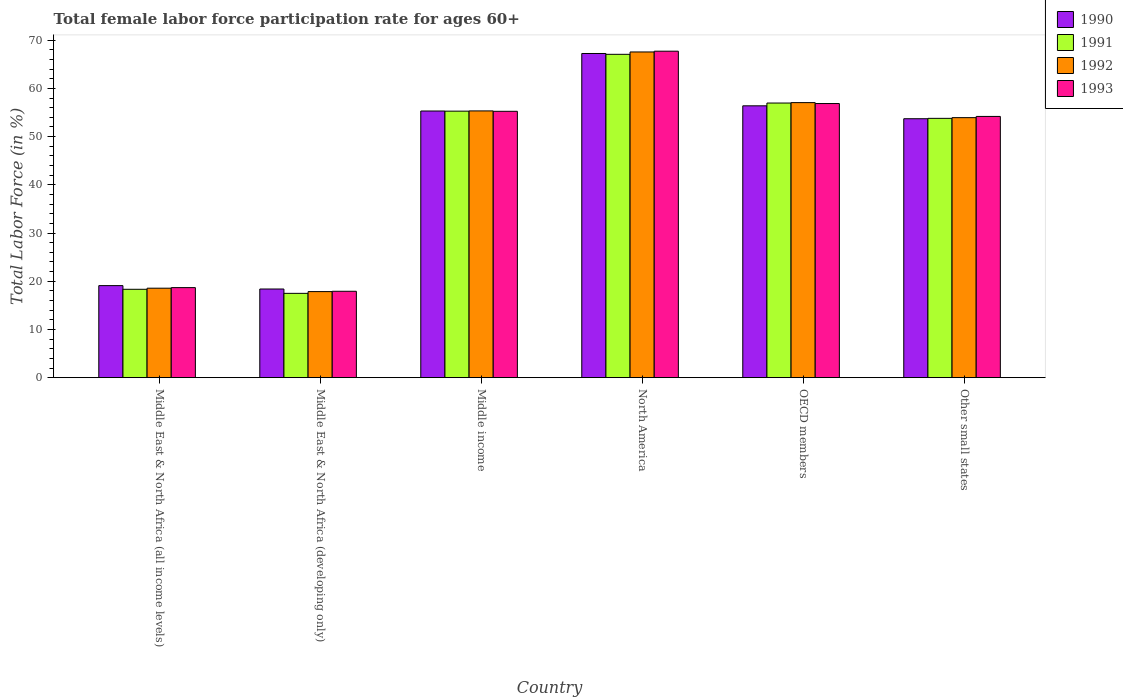Are the number of bars per tick equal to the number of legend labels?
Your answer should be very brief. Yes. How many bars are there on the 2nd tick from the left?
Your response must be concise. 4. What is the label of the 1st group of bars from the left?
Provide a short and direct response. Middle East & North Africa (all income levels). In how many cases, is the number of bars for a given country not equal to the number of legend labels?
Provide a short and direct response. 0. What is the female labor force participation rate in 1990 in Middle East & North Africa (all income levels)?
Offer a very short reply. 19.09. Across all countries, what is the maximum female labor force participation rate in 1991?
Your response must be concise. 67.06. Across all countries, what is the minimum female labor force participation rate in 1993?
Your response must be concise. 17.92. In which country was the female labor force participation rate in 1992 maximum?
Provide a short and direct response. North America. In which country was the female labor force participation rate in 1991 minimum?
Give a very brief answer. Middle East & North Africa (developing only). What is the total female labor force participation rate in 1992 in the graph?
Offer a very short reply. 270.26. What is the difference between the female labor force participation rate in 1991 in North America and that in Other small states?
Make the answer very short. 13.28. What is the difference between the female labor force participation rate in 1990 in OECD members and the female labor force participation rate in 1992 in Middle East & North Africa (developing only)?
Offer a very short reply. 38.53. What is the average female labor force participation rate in 1992 per country?
Your response must be concise. 45.04. What is the difference between the female labor force participation rate of/in 1990 and female labor force participation rate of/in 1991 in Other small states?
Your answer should be compact. -0.08. What is the ratio of the female labor force participation rate in 1991 in Middle East & North Africa (developing only) to that in Middle income?
Provide a short and direct response. 0.32. Is the difference between the female labor force participation rate in 1990 in Middle East & North Africa (developing only) and Other small states greater than the difference between the female labor force participation rate in 1991 in Middle East & North Africa (developing only) and Other small states?
Provide a succinct answer. Yes. What is the difference between the highest and the second highest female labor force participation rate in 1992?
Offer a very short reply. -10.51. What is the difference between the highest and the lowest female labor force participation rate in 1992?
Provide a succinct answer. 49.7. What does the 3rd bar from the left in Middle East & North Africa (developing only) represents?
Your response must be concise. 1992. Is it the case that in every country, the sum of the female labor force participation rate in 1993 and female labor force participation rate in 1990 is greater than the female labor force participation rate in 1991?
Provide a short and direct response. Yes. How many bars are there?
Give a very brief answer. 24. Are all the bars in the graph horizontal?
Offer a very short reply. No. What is the difference between two consecutive major ticks on the Y-axis?
Offer a terse response. 10. Does the graph contain any zero values?
Your answer should be very brief. No. What is the title of the graph?
Ensure brevity in your answer.  Total female labor force participation rate for ages 60+. Does "2006" appear as one of the legend labels in the graph?
Keep it short and to the point. No. What is the label or title of the X-axis?
Your answer should be very brief. Country. What is the label or title of the Y-axis?
Keep it short and to the point. Total Labor Force (in %). What is the Total Labor Force (in %) of 1990 in Middle East & North Africa (all income levels)?
Offer a very short reply. 19.09. What is the Total Labor Force (in %) in 1991 in Middle East & North Africa (all income levels)?
Offer a terse response. 18.33. What is the Total Labor Force (in %) of 1992 in Middle East & North Africa (all income levels)?
Your answer should be very brief. 18.56. What is the Total Labor Force (in %) in 1993 in Middle East & North Africa (all income levels)?
Keep it short and to the point. 18.68. What is the Total Labor Force (in %) of 1990 in Middle East & North Africa (developing only)?
Provide a succinct answer. 18.39. What is the Total Labor Force (in %) of 1991 in Middle East & North Africa (developing only)?
Make the answer very short. 17.49. What is the Total Labor Force (in %) in 1992 in Middle East & North Africa (developing only)?
Ensure brevity in your answer.  17.85. What is the Total Labor Force (in %) in 1993 in Middle East & North Africa (developing only)?
Keep it short and to the point. 17.92. What is the Total Labor Force (in %) in 1990 in Middle income?
Provide a short and direct response. 55.31. What is the Total Labor Force (in %) of 1991 in Middle income?
Offer a terse response. 55.28. What is the Total Labor Force (in %) of 1992 in Middle income?
Offer a very short reply. 55.33. What is the Total Labor Force (in %) of 1993 in Middle income?
Your response must be concise. 55.24. What is the Total Labor Force (in %) in 1990 in North America?
Provide a short and direct response. 67.23. What is the Total Labor Force (in %) of 1991 in North America?
Make the answer very short. 67.06. What is the Total Labor Force (in %) of 1992 in North America?
Provide a succinct answer. 67.55. What is the Total Labor Force (in %) of 1993 in North America?
Provide a short and direct response. 67.71. What is the Total Labor Force (in %) in 1990 in OECD members?
Offer a terse response. 56.38. What is the Total Labor Force (in %) of 1991 in OECD members?
Give a very brief answer. 56.96. What is the Total Labor Force (in %) in 1992 in OECD members?
Make the answer very short. 57.05. What is the Total Labor Force (in %) in 1993 in OECD members?
Provide a short and direct response. 56.86. What is the Total Labor Force (in %) of 1990 in Other small states?
Your response must be concise. 53.71. What is the Total Labor Force (in %) of 1991 in Other small states?
Provide a succinct answer. 53.78. What is the Total Labor Force (in %) of 1992 in Other small states?
Give a very brief answer. 53.93. What is the Total Labor Force (in %) in 1993 in Other small states?
Offer a very short reply. 54.18. Across all countries, what is the maximum Total Labor Force (in %) of 1990?
Make the answer very short. 67.23. Across all countries, what is the maximum Total Labor Force (in %) in 1991?
Ensure brevity in your answer.  67.06. Across all countries, what is the maximum Total Labor Force (in %) in 1992?
Keep it short and to the point. 67.55. Across all countries, what is the maximum Total Labor Force (in %) in 1993?
Provide a succinct answer. 67.71. Across all countries, what is the minimum Total Labor Force (in %) of 1990?
Provide a short and direct response. 18.39. Across all countries, what is the minimum Total Labor Force (in %) of 1991?
Ensure brevity in your answer.  17.49. Across all countries, what is the minimum Total Labor Force (in %) of 1992?
Your answer should be very brief. 17.85. Across all countries, what is the minimum Total Labor Force (in %) in 1993?
Provide a short and direct response. 17.92. What is the total Total Labor Force (in %) in 1990 in the graph?
Offer a very short reply. 270.1. What is the total Total Labor Force (in %) in 1991 in the graph?
Keep it short and to the point. 268.9. What is the total Total Labor Force (in %) of 1992 in the graph?
Provide a short and direct response. 270.26. What is the total Total Labor Force (in %) in 1993 in the graph?
Provide a short and direct response. 270.59. What is the difference between the Total Labor Force (in %) in 1990 in Middle East & North Africa (all income levels) and that in Middle East & North Africa (developing only)?
Make the answer very short. 0.7. What is the difference between the Total Labor Force (in %) of 1991 in Middle East & North Africa (all income levels) and that in Middle East & North Africa (developing only)?
Provide a succinct answer. 0.84. What is the difference between the Total Labor Force (in %) of 1992 in Middle East & North Africa (all income levels) and that in Middle East & North Africa (developing only)?
Provide a succinct answer. 0.71. What is the difference between the Total Labor Force (in %) of 1993 in Middle East & North Africa (all income levels) and that in Middle East & North Africa (developing only)?
Offer a very short reply. 0.76. What is the difference between the Total Labor Force (in %) of 1990 in Middle East & North Africa (all income levels) and that in Middle income?
Your answer should be very brief. -36.21. What is the difference between the Total Labor Force (in %) of 1991 in Middle East & North Africa (all income levels) and that in Middle income?
Provide a short and direct response. -36.95. What is the difference between the Total Labor Force (in %) of 1992 in Middle East & North Africa (all income levels) and that in Middle income?
Offer a very short reply. -36.77. What is the difference between the Total Labor Force (in %) of 1993 in Middle East & North Africa (all income levels) and that in Middle income?
Your response must be concise. -36.57. What is the difference between the Total Labor Force (in %) in 1990 in Middle East & North Africa (all income levels) and that in North America?
Offer a very short reply. -48.14. What is the difference between the Total Labor Force (in %) in 1991 in Middle East & North Africa (all income levels) and that in North America?
Make the answer very short. -48.73. What is the difference between the Total Labor Force (in %) of 1992 in Middle East & North Africa (all income levels) and that in North America?
Make the answer very short. -48.99. What is the difference between the Total Labor Force (in %) in 1993 in Middle East & North Africa (all income levels) and that in North America?
Give a very brief answer. -49.03. What is the difference between the Total Labor Force (in %) in 1990 in Middle East & North Africa (all income levels) and that in OECD members?
Ensure brevity in your answer.  -37.29. What is the difference between the Total Labor Force (in %) in 1991 in Middle East & North Africa (all income levels) and that in OECD members?
Your response must be concise. -38.63. What is the difference between the Total Labor Force (in %) in 1992 in Middle East & North Africa (all income levels) and that in OECD members?
Offer a very short reply. -38.49. What is the difference between the Total Labor Force (in %) of 1993 in Middle East & North Africa (all income levels) and that in OECD members?
Your answer should be compact. -38.18. What is the difference between the Total Labor Force (in %) in 1990 in Middle East & North Africa (all income levels) and that in Other small states?
Provide a short and direct response. -34.61. What is the difference between the Total Labor Force (in %) in 1991 in Middle East & North Africa (all income levels) and that in Other small states?
Provide a succinct answer. -35.45. What is the difference between the Total Labor Force (in %) in 1992 in Middle East & North Africa (all income levels) and that in Other small states?
Offer a very short reply. -35.37. What is the difference between the Total Labor Force (in %) in 1993 in Middle East & North Africa (all income levels) and that in Other small states?
Offer a very short reply. -35.51. What is the difference between the Total Labor Force (in %) of 1990 in Middle East & North Africa (developing only) and that in Middle income?
Offer a very short reply. -36.92. What is the difference between the Total Labor Force (in %) of 1991 in Middle East & North Africa (developing only) and that in Middle income?
Offer a very short reply. -37.79. What is the difference between the Total Labor Force (in %) in 1992 in Middle East & North Africa (developing only) and that in Middle income?
Keep it short and to the point. -37.48. What is the difference between the Total Labor Force (in %) of 1993 in Middle East & North Africa (developing only) and that in Middle income?
Your answer should be very brief. -37.32. What is the difference between the Total Labor Force (in %) in 1990 in Middle East & North Africa (developing only) and that in North America?
Keep it short and to the point. -48.85. What is the difference between the Total Labor Force (in %) of 1991 in Middle East & North Africa (developing only) and that in North America?
Ensure brevity in your answer.  -49.58. What is the difference between the Total Labor Force (in %) of 1992 in Middle East & North Africa (developing only) and that in North America?
Your answer should be very brief. -49.7. What is the difference between the Total Labor Force (in %) in 1993 in Middle East & North Africa (developing only) and that in North America?
Provide a short and direct response. -49.79. What is the difference between the Total Labor Force (in %) in 1990 in Middle East & North Africa (developing only) and that in OECD members?
Give a very brief answer. -38. What is the difference between the Total Labor Force (in %) in 1991 in Middle East & North Africa (developing only) and that in OECD members?
Provide a short and direct response. -39.47. What is the difference between the Total Labor Force (in %) in 1992 in Middle East & North Africa (developing only) and that in OECD members?
Ensure brevity in your answer.  -39.2. What is the difference between the Total Labor Force (in %) in 1993 in Middle East & North Africa (developing only) and that in OECD members?
Provide a short and direct response. -38.94. What is the difference between the Total Labor Force (in %) in 1990 in Middle East & North Africa (developing only) and that in Other small states?
Keep it short and to the point. -35.32. What is the difference between the Total Labor Force (in %) of 1991 in Middle East & North Africa (developing only) and that in Other small states?
Provide a succinct answer. -36.3. What is the difference between the Total Labor Force (in %) of 1992 in Middle East & North Africa (developing only) and that in Other small states?
Provide a succinct answer. -36.08. What is the difference between the Total Labor Force (in %) of 1993 in Middle East & North Africa (developing only) and that in Other small states?
Provide a succinct answer. -36.26. What is the difference between the Total Labor Force (in %) of 1990 in Middle income and that in North America?
Give a very brief answer. -11.93. What is the difference between the Total Labor Force (in %) in 1991 in Middle income and that in North America?
Offer a very short reply. -11.79. What is the difference between the Total Labor Force (in %) in 1992 in Middle income and that in North America?
Your answer should be compact. -12.23. What is the difference between the Total Labor Force (in %) of 1993 in Middle income and that in North America?
Provide a succinct answer. -12.47. What is the difference between the Total Labor Force (in %) in 1990 in Middle income and that in OECD members?
Provide a short and direct response. -1.08. What is the difference between the Total Labor Force (in %) of 1991 in Middle income and that in OECD members?
Your answer should be very brief. -1.68. What is the difference between the Total Labor Force (in %) in 1992 in Middle income and that in OECD members?
Your response must be concise. -1.72. What is the difference between the Total Labor Force (in %) in 1993 in Middle income and that in OECD members?
Your answer should be compact. -1.61. What is the difference between the Total Labor Force (in %) in 1990 in Middle income and that in Other small states?
Your answer should be very brief. 1.6. What is the difference between the Total Labor Force (in %) in 1991 in Middle income and that in Other small states?
Your answer should be compact. 1.5. What is the difference between the Total Labor Force (in %) in 1992 in Middle income and that in Other small states?
Make the answer very short. 1.4. What is the difference between the Total Labor Force (in %) in 1993 in Middle income and that in Other small states?
Your answer should be compact. 1.06. What is the difference between the Total Labor Force (in %) in 1990 in North America and that in OECD members?
Your response must be concise. 10.85. What is the difference between the Total Labor Force (in %) in 1991 in North America and that in OECD members?
Your answer should be compact. 10.11. What is the difference between the Total Labor Force (in %) of 1992 in North America and that in OECD members?
Your response must be concise. 10.51. What is the difference between the Total Labor Force (in %) of 1993 in North America and that in OECD members?
Keep it short and to the point. 10.85. What is the difference between the Total Labor Force (in %) in 1990 in North America and that in Other small states?
Provide a succinct answer. 13.53. What is the difference between the Total Labor Force (in %) in 1991 in North America and that in Other small states?
Your response must be concise. 13.28. What is the difference between the Total Labor Force (in %) in 1992 in North America and that in Other small states?
Offer a terse response. 13.62. What is the difference between the Total Labor Force (in %) of 1993 in North America and that in Other small states?
Your answer should be compact. 13.53. What is the difference between the Total Labor Force (in %) in 1990 in OECD members and that in Other small states?
Make the answer very short. 2.68. What is the difference between the Total Labor Force (in %) of 1991 in OECD members and that in Other small states?
Keep it short and to the point. 3.17. What is the difference between the Total Labor Force (in %) of 1992 in OECD members and that in Other small states?
Your answer should be very brief. 3.12. What is the difference between the Total Labor Force (in %) in 1993 in OECD members and that in Other small states?
Keep it short and to the point. 2.67. What is the difference between the Total Labor Force (in %) in 1990 in Middle East & North Africa (all income levels) and the Total Labor Force (in %) in 1991 in Middle East & North Africa (developing only)?
Give a very brief answer. 1.6. What is the difference between the Total Labor Force (in %) of 1990 in Middle East & North Africa (all income levels) and the Total Labor Force (in %) of 1992 in Middle East & North Africa (developing only)?
Provide a short and direct response. 1.24. What is the difference between the Total Labor Force (in %) of 1990 in Middle East & North Africa (all income levels) and the Total Labor Force (in %) of 1993 in Middle East & North Africa (developing only)?
Your answer should be compact. 1.17. What is the difference between the Total Labor Force (in %) in 1991 in Middle East & North Africa (all income levels) and the Total Labor Force (in %) in 1992 in Middle East & North Africa (developing only)?
Give a very brief answer. 0.48. What is the difference between the Total Labor Force (in %) in 1991 in Middle East & North Africa (all income levels) and the Total Labor Force (in %) in 1993 in Middle East & North Africa (developing only)?
Offer a terse response. 0.41. What is the difference between the Total Labor Force (in %) of 1992 in Middle East & North Africa (all income levels) and the Total Labor Force (in %) of 1993 in Middle East & North Africa (developing only)?
Offer a very short reply. 0.64. What is the difference between the Total Labor Force (in %) of 1990 in Middle East & North Africa (all income levels) and the Total Labor Force (in %) of 1991 in Middle income?
Offer a terse response. -36.19. What is the difference between the Total Labor Force (in %) of 1990 in Middle East & North Africa (all income levels) and the Total Labor Force (in %) of 1992 in Middle income?
Your answer should be compact. -36.23. What is the difference between the Total Labor Force (in %) in 1990 in Middle East & North Africa (all income levels) and the Total Labor Force (in %) in 1993 in Middle income?
Make the answer very short. -36.15. What is the difference between the Total Labor Force (in %) in 1991 in Middle East & North Africa (all income levels) and the Total Labor Force (in %) in 1992 in Middle income?
Ensure brevity in your answer.  -37. What is the difference between the Total Labor Force (in %) of 1991 in Middle East & North Africa (all income levels) and the Total Labor Force (in %) of 1993 in Middle income?
Provide a short and direct response. -36.91. What is the difference between the Total Labor Force (in %) in 1992 in Middle East & North Africa (all income levels) and the Total Labor Force (in %) in 1993 in Middle income?
Keep it short and to the point. -36.69. What is the difference between the Total Labor Force (in %) in 1990 in Middle East & North Africa (all income levels) and the Total Labor Force (in %) in 1991 in North America?
Your response must be concise. -47.97. What is the difference between the Total Labor Force (in %) of 1990 in Middle East & North Africa (all income levels) and the Total Labor Force (in %) of 1992 in North America?
Your answer should be compact. -48.46. What is the difference between the Total Labor Force (in %) in 1990 in Middle East & North Africa (all income levels) and the Total Labor Force (in %) in 1993 in North America?
Offer a terse response. -48.62. What is the difference between the Total Labor Force (in %) of 1991 in Middle East & North Africa (all income levels) and the Total Labor Force (in %) of 1992 in North America?
Ensure brevity in your answer.  -49.22. What is the difference between the Total Labor Force (in %) in 1991 in Middle East & North Africa (all income levels) and the Total Labor Force (in %) in 1993 in North America?
Offer a terse response. -49.38. What is the difference between the Total Labor Force (in %) of 1992 in Middle East & North Africa (all income levels) and the Total Labor Force (in %) of 1993 in North America?
Give a very brief answer. -49.15. What is the difference between the Total Labor Force (in %) in 1990 in Middle East & North Africa (all income levels) and the Total Labor Force (in %) in 1991 in OECD members?
Your response must be concise. -37.87. What is the difference between the Total Labor Force (in %) of 1990 in Middle East & North Africa (all income levels) and the Total Labor Force (in %) of 1992 in OECD members?
Offer a very short reply. -37.95. What is the difference between the Total Labor Force (in %) in 1990 in Middle East & North Africa (all income levels) and the Total Labor Force (in %) in 1993 in OECD members?
Offer a very short reply. -37.76. What is the difference between the Total Labor Force (in %) in 1991 in Middle East & North Africa (all income levels) and the Total Labor Force (in %) in 1992 in OECD members?
Keep it short and to the point. -38.72. What is the difference between the Total Labor Force (in %) in 1991 in Middle East & North Africa (all income levels) and the Total Labor Force (in %) in 1993 in OECD members?
Offer a terse response. -38.53. What is the difference between the Total Labor Force (in %) of 1992 in Middle East & North Africa (all income levels) and the Total Labor Force (in %) of 1993 in OECD members?
Offer a terse response. -38.3. What is the difference between the Total Labor Force (in %) in 1990 in Middle East & North Africa (all income levels) and the Total Labor Force (in %) in 1991 in Other small states?
Offer a terse response. -34.69. What is the difference between the Total Labor Force (in %) of 1990 in Middle East & North Africa (all income levels) and the Total Labor Force (in %) of 1992 in Other small states?
Offer a very short reply. -34.84. What is the difference between the Total Labor Force (in %) of 1990 in Middle East & North Africa (all income levels) and the Total Labor Force (in %) of 1993 in Other small states?
Your response must be concise. -35.09. What is the difference between the Total Labor Force (in %) in 1991 in Middle East & North Africa (all income levels) and the Total Labor Force (in %) in 1992 in Other small states?
Keep it short and to the point. -35.6. What is the difference between the Total Labor Force (in %) of 1991 in Middle East & North Africa (all income levels) and the Total Labor Force (in %) of 1993 in Other small states?
Ensure brevity in your answer.  -35.85. What is the difference between the Total Labor Force (in %) of 1992 in Middle East & North Africa (all income levels) and the Total Labor Force (in %) of 1993 in Other small states?
Make the answer very short. -35.63. What is the difference between the Total Labor Force (in %) in 1990 in Middle East & North Africa (developing only) and the Total Labor Force (in %) in 1991 in Middle income?
Make the answer very short. -36.89. What is the difference between the Total Labor Force (in %) of 1990 in Middle East & North Africa (developing only) and the Total Labor Force (in %) of 1992 in Middle income?
Your answer should be very brief. -36.94. What is the difference between the Total Labor Force (in %) of 1990 in Middle East & North Africa (developing only) and the Total Labor Force (in %) of 1993 in Middle income?
Offer a terse response. -36.86. What is the difference between the Total Labor Force (in %) of 1991 in Middle East & North Africa (developing only) and the Total Labor Force (in %) of 1992 in Middle income?
Keep it short and to the point. -37.84. What is the difference between the Total Labor Force (in %) in 1991 in Middle East & North Africa (developing only) and the Total Labor Force (in %) in 1993 in Middle income?
Your answer should be very brief. -37.76. What is the difference between the Total Labor Force (in %) in 1992 in Middle East & North Africa (developing only) and the Total Labor Force (in %) in 1993 in Middle income?
Offer a very short reply. -37.39. What is the difference between the Total Labor Force (in %) in 1990 in Middle East & North Africa (developing only) and the Total Labor Force (in %) in 1991 in North America?
Give a very brief answer. -48.68. What is the difference between the Total Labor Force (in %) in 1990 in Middle East & North Africa (developing only) and the Total Labor Force (in %) in 1992 in North America?
Your answer should be very brief. -49.16. What is the difference between the Total Labor Force (in %) in 1990 in Middle East & North Africa (developing only) and the Total Labor Force (in %) in 1993 in North America?
Offer a very short reply. -49.32. What is the difference between the Total Labor Force (in %) in 1991 in Middle East & North Africa (developing only) and the Total Labor Force (in %) in 1992 in North America?
Your answer should be compact. -50.06. What is the difference between the Total Labor Force (in %) in 1991 in Middle East & North Africa (developing only) and the Total Labor Force (in %) in 1993 in North America?
Offer a terse response. -50.22. What is the difference between the Total Labor Force (in %) of 1992 in Middle East & North Africa (developing only) and the Total Labor Force (in %) of 1993 in North America?
Provide a short and direct response. -49.86. What is the difference between the Total Labor Force (in %) in 1990 in Middle East & North Africa (developing only) and the Total Labor Force (in %) in 1991 in OECD members?
Your response must be concise. -38.57. What is the difference between the Total Labor Force (in %) of 1990 in Middle East & North Africa (developing only) and the Total Labor Force (in %) of 1992 in OECD members?
Make the answer very short. -38.66. What is the difference between the Total Labor Force (in %) in 1990 in Middle East & North Africa (developing only) and the Total Labor Force (in %) in 1993 in OECD members?
Offer a very short reply. -38.47. What is the difference between the Total Labor Force (in %) of 1991 in Middle East & North Africa (developing only) and the Total Labor Force (in %) of 1992 in OECD members?
Ensure brevity in your answer.  -39.56. What is the difference between the Total Labor Force (in %) of 1991 in Middle East & North Africa (developing only) and the Total Labor Force (in %) of 1993 in OECD members?
Your answer should be very brief. -39.37. What is the difference between the Total Labor Force (in %) of 1992 in Middle East & North Africa (developing only) and the Total Labor Force (in %) of 1993 in OECD members?
Offer a very short reply. -39.01. What is the difference between the Total Labor Force (in %) in 1990 in Middle East & North Africa (developing only) and the Total Labor Force (in %) in 1991 in Other small states?
Provide a short and direct response. -35.4. What is the difference between the Total Labor Force (in %) in 1990 in Middle East & North Africa (developing only) and the Total Labor Force (in %) in 1992 in Other small states?
Provide a succinct answer. -35.54. What is the difference between the Total Labor Force (in %) in 1990 in Middle East & North Africa (developing only) and the Total Labor Force (in %) in 1993 in Other small states?
Provide a succinct answer. -35.8. What is the difference between the Total Labor Force (in %) in 1991 in Middle East & North Africa (developing only) and the Total Labor Force (in %) in 1992 in Other small states?
Ensure brevity in your answer.  -36.44. What is the difference between the Total Labor Force (in %) in 1991 in Middle East & North Africa (developing only) and the Total Labor Force (in %) in 1993 in Other small states?
Keep it short and to the point. -36.7. What is the difference between the Total Labor Force (in %) of 1992 in Middle East & North Africa (developing only) and the Total Labor Force (in %) of 1993 in Other small states?
Ensure brevity in your answer.  -36.33. What is the difference between the Total Labor Force (in %) of 1990 in Middle income and the Total Labor Force (in %) of 1991 in North America?
Your answer should be compact. -11.76. What is the difference between the Total Labor Force (in %) in 1990 in Middle income and the Total Labor Force (in %) in 1992 in North America?
Your response must be concise. -12.25. What is the difference between the Total Labor Force (in %) in 1990 in Middle income and the Total Labor Force (in %) in 1993 in North America?
Offer a very short reply. -12.4. What is the difference between the Total Labor Force (in %) of 1991 in Middle income and the Total Labor Force (in %) of 1992 in North America?
Offer a very short reply. -12.27. What is the difference between the Total Labor Force (in %) in 1991 in Middle income and the Total Labor Force (in %) in 1993 in North America?
Offer a terse response. -12.43. What is the difference between the Total Labor Force (in %) in 1992 in Middle income and the Total Labor Force (in %) in 1993 in North America?
Offer a very short reply. -12.38. What is the difference between the Total Labor Force (in %) of 1990 in Middle income and the Total Labor Force (in %) of 1991 in OECD members?
Give a very brief answer. -1.65. What is the difference between the Total Labor Force (in %) in 1990 in Middle income and the Total Labor Force (in %) in 1992 in OECD members?
Make the answer very short. -1.74. What is the difference between the Total Labor Force (in %) in 1990 in Middle income and the Total Labor Force (in %) in 1993 in OECD members?
Your answer should be compact. -1.55. What is the difference between the Total Labor Force (in %) of 1991 in Middle income and the Total Labor Force (in %) of 1992 in OECD members?
Your response must be concise. -1.77. What is the difference between the Total Labor Force (in %) in 1991 in Middle income and the Total Labor Force (in %) in 1993 in OECD members?
Provide a short and direct response. -1.58. What is the difference between the Total Labor Force (in %) in 1992 in Middle income and the Total Labor Force (in %) in 1993 in OECD members?
Offer a terse response. -1.53. What is the difference between the Total Labor Force (in %) of 1990 in Middle income and the Total Labor Force (in %) of 1991 in Other small states?
Your response must be concise. 1.52. What is the difference between the Total Labor Force (in %) of 1990 in Middle income and the Total Labor Force (in %) of 1992 in Other small states?
Make the answer very short. 1.38. What is the difference between the Total Labor Force (in %) of 1990 in Middle income and the Total Labor Force (in %) of 1993 in Other small states?
Your answer should be very brief. 1.12. What is the difference between the Total Labor Force (in %) of 1991 in Middle income and the Total Labor Force (in %) of 1992 in Other small states?
Offer a terse response. 1.35. What is the difference between the Total Labor Force (in %) in 1991 in Middle income and the Total Labor Force (in %) in 1993 in Other small states?
Provide a short and direct response. 1.1. What is the difference between the Total Labor Force (in %) in 1992 in Middle income and the Total Labor Force (in %) in 1993 in Other small states?
Ensure brevity in your answer.  1.14. What is the difference between the Total Labor Force (in %) of 1990 in North America and the Total Labor Force (in %) of 1991 in OECD members?
Your answer should be very brief. 10.28. What is the difference between the Total Labor Force (in %) in 1990 in North America and the Total Labor Force (in %) in 1992 in OECD members?
Offer a terse response. 10.19. What is the difference between the Total Labor Force (in %) of 1990 in North America and the Total Labor Force (in %) of 1993 in OECD members?
Provide a short and direct response. 10.38. What is the difference between the Total Labor Force (in %) in 1991 in North America and the Total Labor Force (in %) in 1992 in OECD members?
Your response must be concise. 10.02. What is the difference between the Total Labor Force (in %) of 1991 in North America and the Total Labor Force (in %) of 1993 in OECD members?
Your answer should be compact. 10.21. What is the difference between the Total Labor Force (in %) of 1992 in North America and the Total Labor Force (in %) of 1993 in OECD members?
Provide a short and direct response. 10.7. What is the difference between the Total Labor Force (in %) in 1990 in North America and the Total Labor Force (in %) in 1991 in Other small states?
Give a very brief answer. 13.45. What is the difference between the Total Labor Force (in %) of 1990 in North America and the Total Labor Force (in %) of 1992 in Other small states?
Your answer should be very brief. 13.31. What is the difference between the Total Labor Force (in %) of 1990 in North America and the Total Labor Force (in %) of 1993 in Other small states?
Your answer should be compact. 13.05. What is the difference between the Total Labor Force (in %) of 1991 in North America and the Total Labor Force (in %) of 1992 in Other small states?
Make the answer very short. 13.14. What is the difference between the Total Labor Force (in %) in 1991 in North America and the Total Labor Force (in %) in 1993 in Other small states?
Give a very brief answer. 12.88. What is the difference between the Total Labor Force (in %) of 1992 in North America and the Total Labor Force (in %) of 1993 in Other small states?
Make the answer very short. 13.37. What is the difference between the Total Labor Force (in %) of 1990 in OECD members and the Total Labor Force (in %) of 1991 in Other small states?
Your response must be concise. 2.6. What is the difference between the Total Labor Force (in %) in 1990 in OECD members and the Total Labor Force (in %) in 1992 in Other small states?
Offer a very short reply. 2.45. What is the difference between the Total Labor Force (in %) in 1990 in OECD members and the Total Labor Force (in %) in 1993 in Other small states?
Make the answer very short. 2.2. What is the difference between the Total Labor Force (in %) in 1991 in OECD members and the Total Labor Force (in %) in 1992 in Other small states?
Make the answer very short. 3.03. What is the difference between the Total Labor Force (in %) in 1991 in OECD members and the Total Labor Force (in %) in 1993 in Other small states?
Keep it short and to the point. 2.78. What is the difference between the Total Labor Force (in %) in 1992 in OECD members and the Total Labor Force (in %) in 1993 in Other small states?
Your answer should be compact. 2.86. What is the average Total Labor Force (in %) in 1990 per country?
Ensure brevity in your answer.  45.02. What is the average Total Labor Force (in %) of 1991 per country?
Make the answer very short. 44.82. What is the average Total Labor Force (in %) in 1992 per country?
Provide a short and direct response. 45.04. What is the average Total Labor Force (in %) of 1993 per country?
Offer a very short reply. 45.1. What is the difference between the Total Labor Force (in %) in 1990 and Total Labor Force (in %) in 1991 in Middle East & North Africa (all income levels)?
Keep it short and to the point. 0.76. What is the difference between the Total Labor Force (in %) in 1990 and Total Labor Force (in %) in 1992 in Middle East & North Africa (all income levels)?
Ensure brevity in your answer.  0.53. What is the difference between the Total Labor Force (in %) of 1990 and Total Labor Force (in %) of 1993 in Middle East & North Africa (all income levels)?
Ensure brevity in your answer.  0.41. What is the difference between the Total Labor Force (in %) in 1991 and Total Labor Force (in %) in 1992 in Middle East & North Africa (all income levels)?
Your answer should be very brief. -0.23. What is the difference between the Total Labor Force (in %) of 1991 and Total Labor Force (in %) of 1993 in Middle East & North Africa (all income levels)?
Provide a short and direct response. -0.35. What is the difference between the Total Labor Force (in %) in 1992 and Total Labor Force (in %) in 1993 in Middle East & North Africa (all income levels)?
Give a very brief answer. -0.12. What is the difference between the Total Labor Force (in %) in 1990 and Total Labor Force (in %) in 1991 in Middle East & North Africa (developing only)?
Keep it short and to the point. 0.9. What is the difference between the Total Labor Force (in %) of 1990 and Total Labor Force (in %) of 1992 in Middle East & North Africa (developing only)?
Provide a short and direct response. 0.54. What is the difference between the Total Labor Force (in %) of 1990 and Total Labor Force (in %) of 1993 in Middle East & North Africa (developing only)?
Your answer should be compact. 0.47. What is the difference between the Total Labor Force (in %) in 1991 and Total Labor Force (in %) in 1992 in Middle East & North Africa (developing only)?
Keep it short and to the point. -0.36. What is the difference between the Total Labor Force (in %) in 1991 and Total Labor Force (in %) in 1993 in Middle East & North Africa (developing only)?
Offer a terse response. -0.43. What is the difference between the Total Labor Force (in %) in 1992 and Total Labor Force (in %) in 1993 in Middle East & North Africa (developing only)?
Your answer should be very brief. -0.07. What is the difference between the Total Labor Force (in %) in 1990 and Total Labor Force (in %) in 1991 in Middle income?
Make the answer very short. 0.03. What is the difference between the Total Labor Force (in %) in 1990 and Total Labor Force (in %) in 1992 in Middle income?
Your answer should be very brief. -0.02. What is the difference between the Total Labor Force (in %) in 1990 and Total Labor Force (in %) in 1993 in Middle income?
Make the answer very short. 0.06. What is the difference between the Total Labor Force (in %) in 1991 and Total Labor Force (in %) in 1992 in Middle income?
Offer a terse response. -0.05. What is the difference between the Total Labor Force (in %) in 1991 and Total Labor Force (in %) in 1993 in Middle income?
Provide a succinct answer. 0.03. What is the difference between the Total Labor Force (in %) of 1992 and Total Labor Force (in %) of 1993 in Middle income?
Make the answer very short. 0.08. What is the difference between the Total Labor Force (in %) in 1990 and Total Labor Force (in %) in 1991 in North America?
Your answer should be very brief. 0.17. What is the difference between the Total Labor Force (in %) in 1990 and Total Labor Force (in %) in 1992 in North America?
Your answer should be very brief. -0.32. What is the difference between the Total Labor Force (in %) of 1990 and Total Labor Force (in %) of 1993 in North America?
Keep it short and to the point. -0.48. What is the difference between the Total Labor Force (in %) in 1991 and Total Labor Force (in %) in 1992 in North America?
Your response must be concise. -0.49. What is the difference between the Total Labor Force (in %) of 1991 and Total Labor Force (in %) of 1993 in North America?
Your response must be concise. -0.65. What is the difference between the Total Labor Force (in %) of 1992 and Total Labor Force (in %) of 1993 in North America?
Ensure brevity in your answer.  -0.16. What is the difference between the Total Labor Force (in %) in 1990 and Total Labor Force (in %) in 1991 in OECD members?
Give a very brief answer. -0.58. What is the difference between the Total Labor Force (in %) in 1990 and Total Labor Force (in %) in 1992 in OECD members?
Make the answer very short. -0.66. What is the difference between the Total Labor Force (in %) in 1990 and Total Labor Force (in %) in 1993 in OECD members?
Your answer should be very brief. -0.47. What is the difference between the Total Labor Force (in %) in 1991 and Total Labor Force (in %) in 1992 in OECD members?
Your answer should be very brief. -0.09. What is the difference between the Total Labor Force (in %) in 1991 and Total Labor Force (in %) in 1993 in OECD members?
Your response must be concise. 0.1. What is the difference between the Total Labor Force (in %) in 1992 and Total Labor Force (in %) in 1993 in OECD members?
Offer a terse response. 0.19. What is the difference between the Total Labor Force (in %) of 1990 and Total Labor Force (in %) of 1991 in Other small states?
Your answer should be compact. -0.08. What is the difference between the Total Labor Force (in %) of 1990 and Total Labor Force (in %) of 1992 in Other small states?
Make the answer very short. -0.22. What is the difference between the Total Labor Force (in %) of 1990 and Total Labor Force (in %) of 1993 in Other small states?
Your response must be concise. -0.48. What is the difference between the Total Labor Force (in %) in 1991 and Total Labor Force (in %) in 1992 in Other small states?
Ensure brevity in your answer.  -0.14. What is the difference between the Total Labor Force (in %) of 1991 and Total Labor Force (in %) of 1993 in Other small states?
Give a very brief answer. -0.4. What is the difference between the Total Labor Force (in %) in 1992 and Total Labor Force (in %) in 1993 in Other small states?
Keep it short and to the point. -0.25. What is the ratio of the Total Labor Force (in %) in 1990 in Middle East & North Africa (all income levels) to that in Middle East & North Africa (developing only)?
Provide a short and direct response. 1.04. What is the ratio of the Total Labor Force (in %) of 1991 in Middle East & North Africa (all income levels) to that in Middle East & North Africa (developing only)?
Provide a succinct answer. 1.05. What is the ratio of the Total Labor Force (in %) in 1992 in Middle East & North Africa (all income levels) to that in Middle East & North Africa (developing only)?
Provide a short and direct response. 1.04. What is the ratio of the Total Labor Force (in %) of 1993 in Middle East & North Africa (all income levels) to that in Middle East & North Africa (developing only)?
Make the answer very short. 1.04. What is the ratio of the Total Labor Force (in %) of 1990 in Middle East & North Africa (all income levels) to that in Middle income?
Ensure brevity in your answer.  0.35. What is the ratio of the Total Labor Force (in %) of 1991 in Middle East & North Africa (all income levels) to that in Middle income?
Your response must be concise. 0.33. What is the ratio of the Total Labor Force (in %) of 1992 in Middle East & North Africa (all income levels) to that in Middle income?
Provide a short and direct response. 0.34. What is the ratio of the Total Labor Force (in %) of 1993 in Middle East & North Africa (all income levels) to that in Middle income?
Keep it short and to the point. 0.34. What is the ratio of the Total Labor Force (in %) in 1990 in Middle East & North Africa (all income levels) to that in North America?
Keep it short and to the point. 0.28. What is the ratio of the Total Labor Force (in %) in 1991 in Middle East & North Africa (all income levels) to that in North America?
Your answer should be very brief. 0.27. What is the ratio of the Total Labor Force (in %) in 1992 in Middle East & North Africa (all income levels) to that in North America?
Provide a short and direct response. 0.27. What is the ratio of the Total Labor Force (in %) of 1993 in Middle East & North Africa (all income levels) to that in North America?
Ensure brevity in your answer.  0.28. What is the ratio of the Total Labor Force (in %) of 1990 in Middle East & North Africa (all income levels) to that in OECD members?
Keep it short and to the point. 0.34. What is the ratio of the Total Labor Force (in %) in 1991 in Middle East & North Africa (all income levels) to that in OECD members?
Offer a very short reply. 0.32. What is the ratio of the Total Labor Force (in %) in 1992 in Middle East & North Africa (all income levels) to that in OECD members?
Your answer should be compact. 0.33. What is the ratio of the Total Labor Force (in %) in 1993 in Middle East & North Africa (all income levels) to that in OECD members?
Give a very brief answer. 0.33. What is the ratio of the Total Labor Force (in %) in 1990 in Middle East & North Africa (all income levels) to that in Other small states?
Provide a succinct answer. 0.36. What is the ratio of the Total Labor Force (in %) of 1991 in Middle East & North Africa (all income levels) to that in Other small states?
Ensure brevity in your answer.  0.34. What is the ratio of the Total Labor Force (in %) of 1992 in Middle East & North Africa (all income levels) to that in Other small states?
Make the answer very short. 0.34. What is the ratio of the Total Labor Force (in %) of 1993 in Middle East & North Africa (all income levels) to that in Other small states?
Offer a terse response. 0.34. What is the ratio of the Total Labor Force (in %) of 1990 in Middle East & North Africa (developing only) to that in Middle income?
Offer a terse response. 0.33. What is the ratio of the Total Labor Force (in %) in 1991 in Middle East & North Africa (developing only) to that in Middle income?
Make the answer very short. 0.32. What is the ratio of the Total Labor Force (in %) in 1992 in Middle East & North Africa (developing only) to that in Middle income?
Give a very brief answer. 0.32. What is the ratio of the Total Labor Force (in %) in 1993 in Middle East & North Africa (developing only) to that in Middle income?
Keep it short and to the point. 0.32. What is the ratio of the Total Labor Force (in %) of 1990 in Middle East & North Africa (developing only) to that in North America?
Make the answer very short. 0.27. What is the ratio of the Total Labor Force (in %) in 1991 in Middle East & North Africa (developing only) to that in North America?
Give a very brief answer. 0.26. What is the ratio of the Total Labor Force (in %) of 1992 in Middle East & North Africa (developing only) to that in North America?
Your response must be concise. 0.26. What is the ratio of the Total Labor Force (in %) in 1993 in Middle East & North Africa (developing only) to that in North America?
Your answer should be very brief. 0.26. What is the ratio of the Total Labor Force (in %) in 1990 in Middle East & North Africa (developing only) to that in OECD members?
Keep it short and to the point. 0.33. What is the ratio of the Total Labor Force (in %) of 1991 in Middle East & North Africa (developing only) to that in OECD members?
Your response must be concise. 0.31. What is the ratio of the Total Labor Force (in %) of 1992 in Middle East & North Africa (developing only) to that in OECD members?
Ensure brevity in your answer.  0.31. What is the ratio of the Total Labor Force (in %) of 1993 in Middle East & North Africa (developing only) to that in OECD members?
Offer a terse response. 0.32. What is the ratio of the Total Labor Force (in %) in 1990 in Middle East & North Africa (developing only) to that in Other small states?
Provide a short and direct response. 0.34. What is the ratio of the Total Labor Force (in %) of 1991 in Middle East & North Africa (developing only) to that in Other small states?
Keep it short and to the point. 0.33. What is the ratio of the Total Labor Force (in %) in 1992 in Middle East & North Africa (developing only) to that in Other small states?
Offer a terse response. 0.33. What is the ratio of the Total Labor Force (in %) in 1993 in Middle East & North Africa (developing only) to that in Other small states?
Make the answer very short. 0.33. What is the ratio of the Total Labor Force (in %) of 1990 in Middle income to that in North America?
Keep it short and to the point. 0.82. What is the ratio of the Total Labor Force (in %) in 1991 in Middle income to that in North America?
Provide a short and direct response. 0.82. What is the ratio of the Total Labor Force (in %) of 1992 in Middle income to that in North America?
Give a very brief answer. 0.82. What is the ratio of the Total Labor Force (in %) in 1993 in Middle income to that in North America?
Offer a very short reply. 0.82. What is the ratio of the Total Labor Force (in %) in 1990 in Middle income to that in OECD members?
Offer a very short reply. 0.98. What is the ratio of the Total Labor Force (in %) in 1991 in Middle income to that in OECD members?
Give a very brief answer. 0.97. What is the ratio of the Total Labor Force (in %) in 1992 in Middle income to that in OECD members?
Provide a short and direct response. 0.97. What is the ratio of the Total Labor Force (in %) in 1993 in Middle income to that in OECD members?
Offer a terse response. 0.97. What is the ratio of the Total Labor Force (in %) of 1990 in Middle income to that in Other small states?
Your response must be concise. 1.03. What is the ratio of the Total Labor Force (in %) in 1991 in Middle income to that in Other small states?
Provide a succinct answer. 1.03. What is the ratio of the Total Labor Force (in %) of 1992 in Middle income to that in Other small states?
Keep it short and to the point. 1.03. What is the ratio of the Total Labor Force (in %) in 1993 in Middle income to that in Other small states?
Offer a very short reply. 1.02. What is the ratio of the Total Labor Force (in %) in 1990 in North America to that in OECD members?
Provide a succinct answer. 1.19. What is the ratio of the Total Labor Force (in %) of 1991 in North America to that in OECD members?
Your answer should be very brief. 1.18. What is the ratio of the Total Labor Force (in %) in 1992 in North America to that in OECD members?
Your answer should be compact. 1.18. What is the ratio of the Total Labor Force (in %) of 1993 in North America to that in OECD members?
Offer a terse response. 1.19. What is the ratio of the Total Labor Force (in %) of 1990 in North America to that in Other small states?
Your response must be concise. 1.25. What is the ratio of the Total Labor Force (in %) of 1991 in North America to that in Other small states?
Ensure brevity in your answer.  1.25. What is the ratio of the Total Labor Force (in %) of 1992 in North America to that in Other small states?
Keep it short and to the point. 1.25. What is the ratio of the Total Labor Force (in %) in 1993 in North America to that in Other small states?
Offer a very short reply. 1.25. What is the ratio of the Total Labor Force (in %) of 1990 in OECD members to that in Other small states?
Make the answer very short. 1.05. What is the ratio of the Total Labor Force (in %) in 1991 in OECD members to that in Other small states?
Provide a short and direct response. 1.06. What is the ratio of the Total Labor Force (in %) in 1992 in OECD members to that in Other small states?
Your response must be concise. 1.06. What is the ratio of the Total Labor Force (in %) in 1993 in OECD members to that in Other small states?
Give a very brief answer. 1.05. What is the difference between the highest and the second highest Total Labor Force (in %) of 1990?
Your answer should be compact. 10.85. What is the difference between the highest and the second highest Total Labor Force (in %) of 1991?
Your answer should be very brief. 10.11. What is the difference between the highest and the second highest Total Labor Force (in %) of 1992?
Provide a succinct answer. 10.51. What is the difference between the highest and the second highest Total Labor Force (in %) in 1993?
Ensure brevity in your answer.  10.85. What is the difference between the highest and the lowest Total Labor Force (in %) of 1990?
Provide a succinct answer. 48.85. What is the difference between the highest and the lowest Total Labor Force (in %) in 1991?
Your response must be concise. 49.58. What is the difference between the highest and the lowest Total Labor Force (in %) of 1992?
Provide a succinct answer. 49.7. What is the difference between the highest and the lowest Total Labor Force (in %) in 1993?
Make the answer very short. 49.79. 